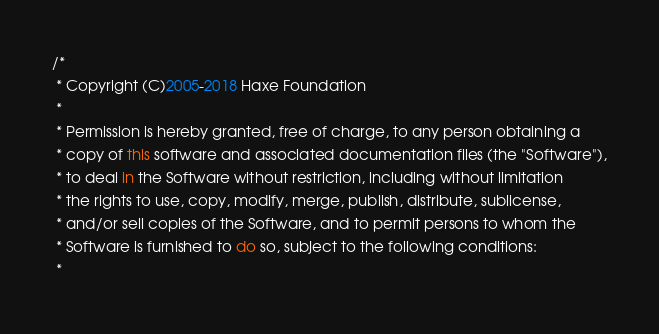<code> <loc_0><loc_0><loc_500><loc_500><_Haxe_>/*
 * Copyright (C)2005-2018 Haxe Foundation
 *
 * Permission is hereby granted, free of charge, to any person obtaining a
 * copy of this software and associated documentation files (the "Software"),
 * to deal in the Software without restriction, including without limitation
 * the rights to use, copy, modify, merge, publish, distribute, sublicense,
 * and/or sell copies of the Software, and to permit persons to whom the
 * Software is furnished to do so, subject to the following conditions:
 *</code> 